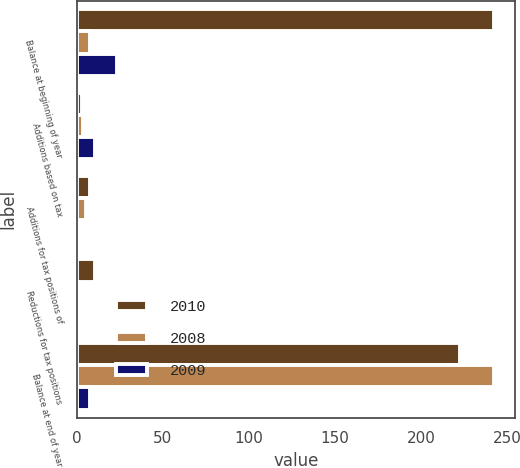Convert chart to OTSL. <chart><loc_0><loc_0><loc_500><loc_500><stacked_bar_chart><ecel><fcel>Balance at beginning of year<fcel>Additions based on tax<fcel>Additions for tax positions of<fcel>Reductions for tax positions<fcel>Balance at end of year<nl><fcel>2010<fcel>242.2<fcel>2.8<fcel>7.5<fcel>10.4<fcel>222.8<nl><fcel>2008<fcel>7.45<fcel>3.9<fcel>5.6<fcel>0.5<fcel>242.2<nl><fcel>2009<fcel>23.2<fcel>10.6<fcel>2<fcel>0.4<fcel>7.45<nl></chart> 